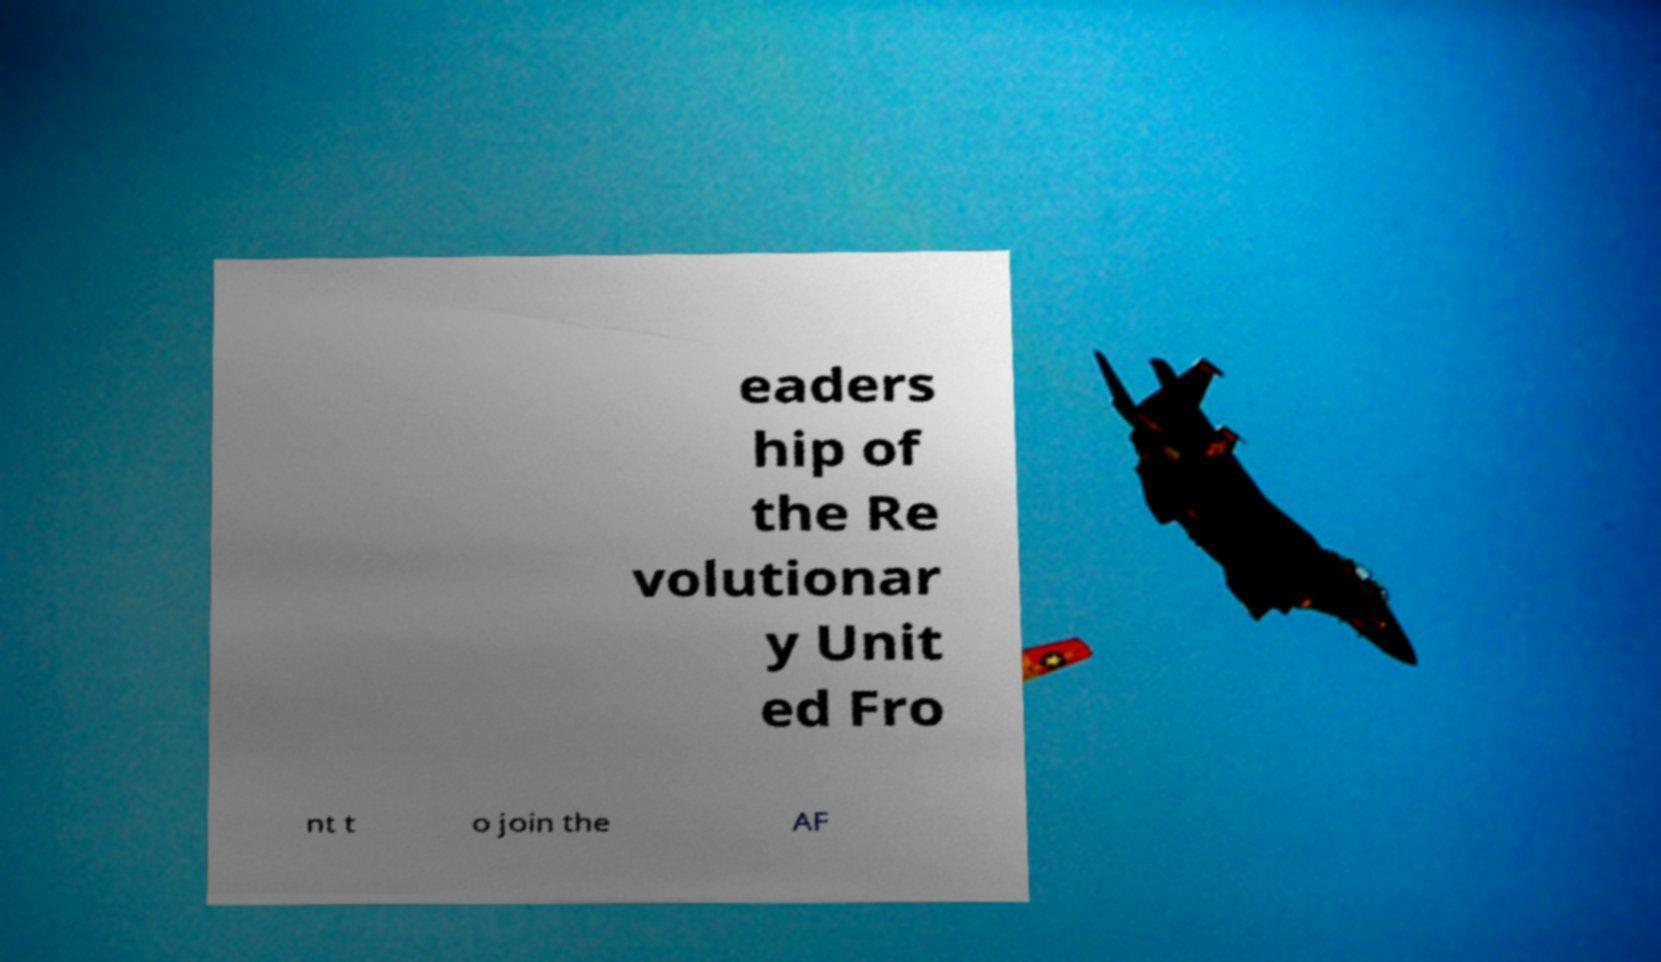What messages or text are displayed in this image? I need them in a readable, typed format. eaders hip of the Re volutionar y Unit ed Fro nt t o join the AF 